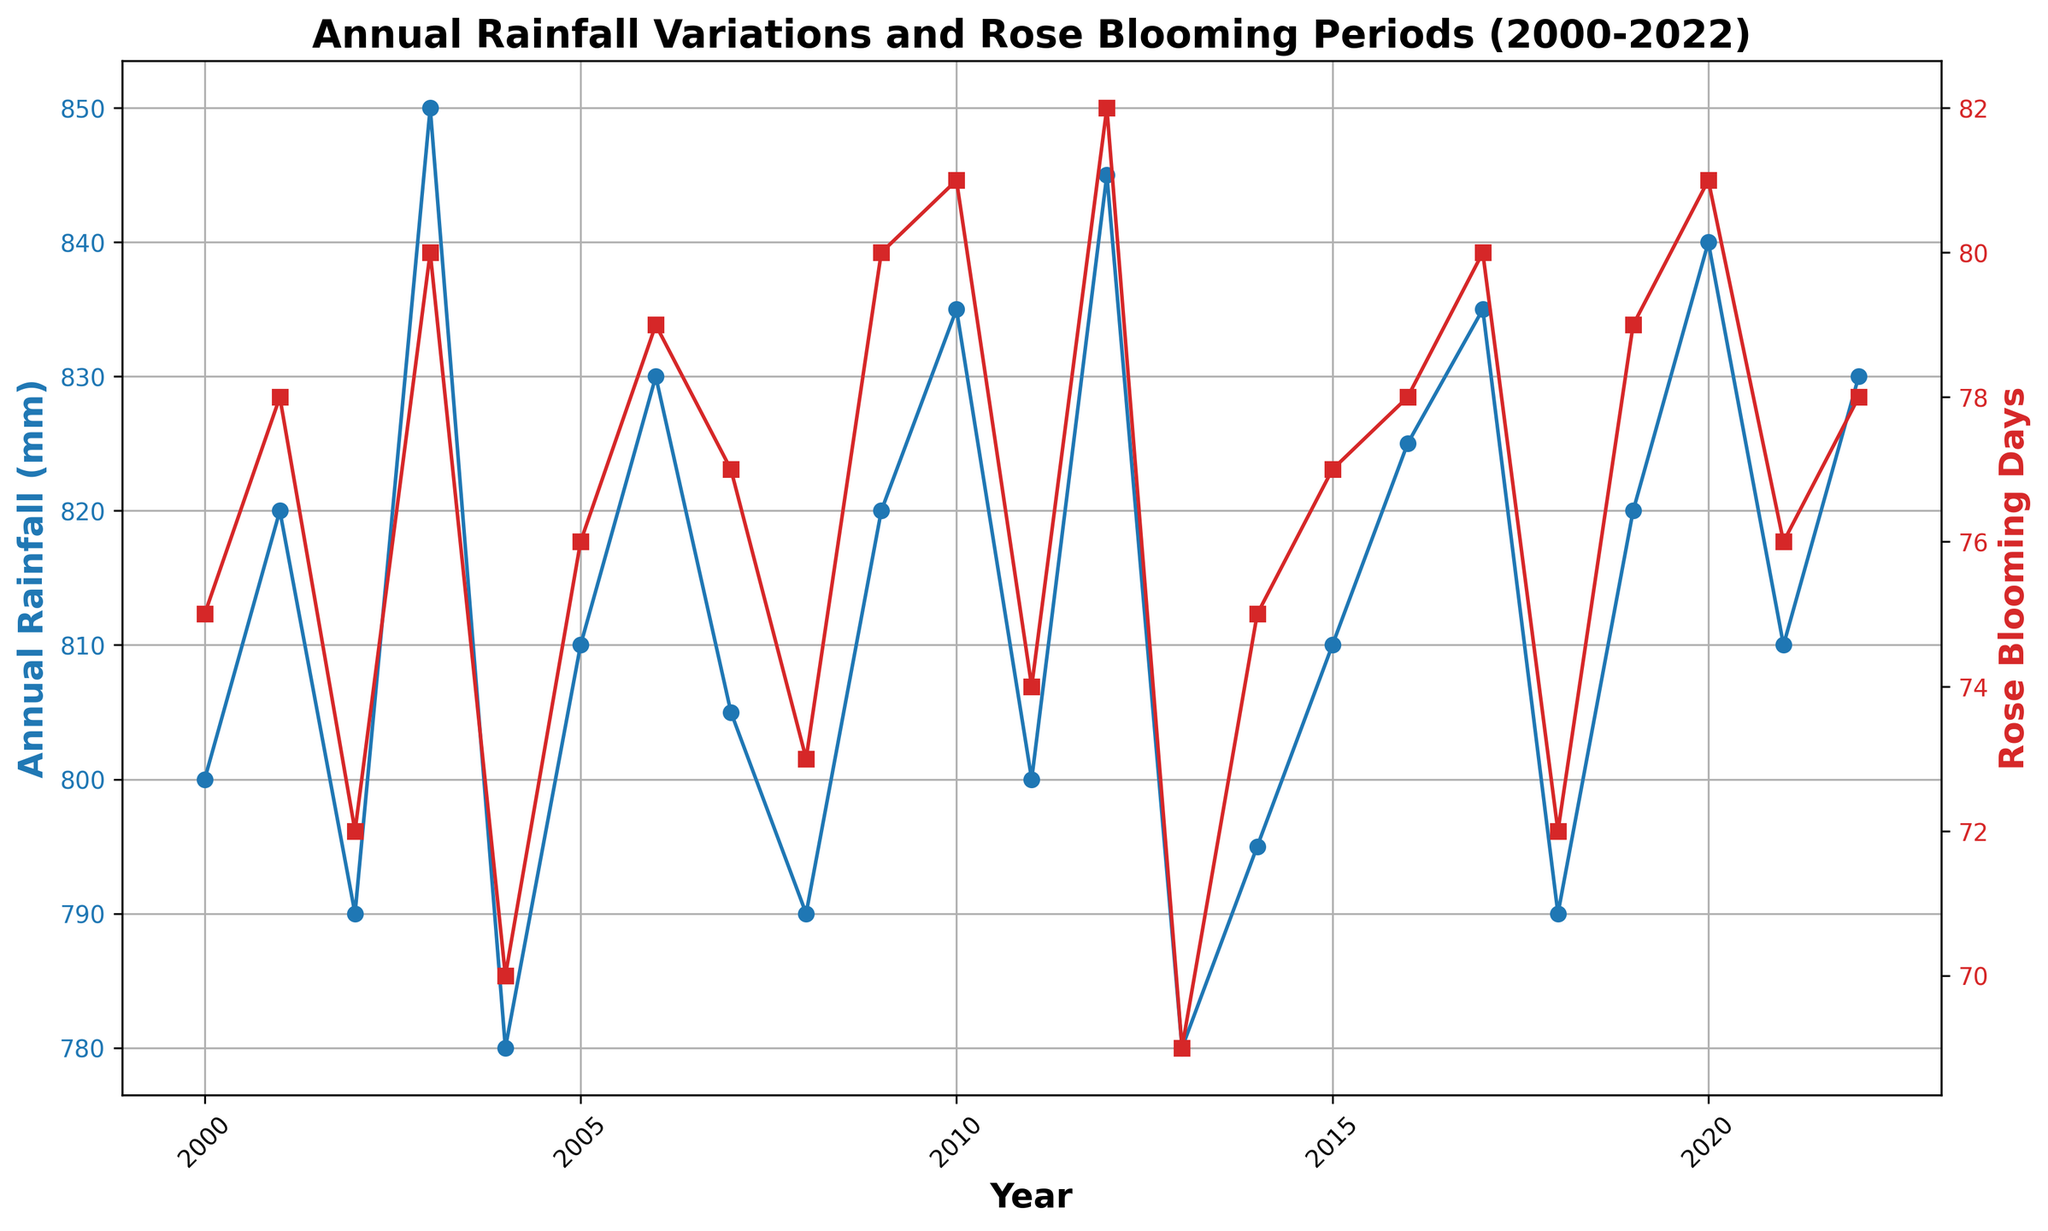How does the Annual Rainfall in 2003 compare to that in 2005? The annual rainfall in 2003 is 850mm, while in 2005 it is 810mm. To compare, we note that 850mm is greater than 810mm.
Answer: 2003 > 2005 What is the relationship between Annual Rainfall and Rose Blooming Days in 2010? In 2010, the annual rainfall is 835mm, and the rose blooming days are 81 days. We observe that both values are relatively high compared to other years, suggesting a possible positive correlation.
Answer: High Rainfall, High Blooming Days How many more Rose Blooming Days are there in 2012 compared to 2013? In 2012, there are 82 rose blooming days, and in 2013, there are 69 blooming days. The difference is calculated as 82 - 69 = 13 days.
Answer: 13 days Identify the year with the maximum Rose Blooming Days and state the corresponding Annual Rainfall. The maximum rose blooming days are 82, occurring in the year 2012. The corresponding annual rainfall is 845mm.
Answer: 2012, 845mm What can we infer about Rose Blooming Days between 2008 and 2010? In 2008, the blooming days are 73, increasing to 80 in 2009 and 81 in 2010. This indicates a rising trend for rose blooming days during this period.
Answer: Increasing Trend Is there a year when the Annual Rainfall and Rose Blooming Days both fell below their respective medians? The median Annual Rainfall is 815mm, and the median Blooming Days is 77. In 2004, both values fall below the medians: 780mm and 70 days respectively.
Answer: 2004 What is the average number of Rose Blooming Days from 2015 to 2018? The rose blooming days for 2015 to 2018 are 77, 78, 80, and 72 respectively. The average is calculated as (77 + 78 + 80 + 72) / 4 = 76.75 days.
Answer: 76.75 days Which year experienced the least Annual Rainfall, and what were the corresponding Rose Blooming Days? The least annual rainfall occurred in 2004 with 780mm, and the corresponding rose blooming days were 70 days.
Answer: 2004, 70 days 